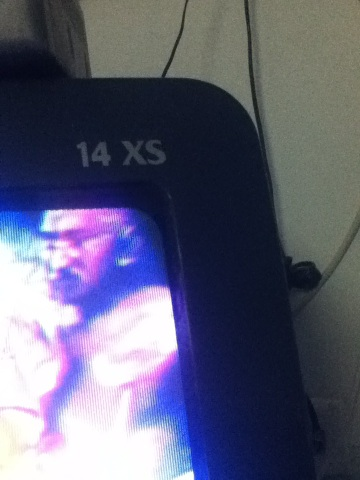Can you identify what this image is depicting? The image appears to be a close-up shot of a television or monitor displaying part of what might be a scene from a video or television program, with the text '14 XS' visible. Due to the blurry nature, it's challenging to identify precise details of the scene being displayed. Is there any part of the image that stands out despite the blur? The most distinctive element is the text '14 XS' on the device, which likely indicates the model or specification of the television or monitor. This detail stands out clearly against the surrounding elements. Imagining the best possible scenario, what could the video on screen be showing? In an imaginative scenario, the video on the screen could be showing a dramatic scene from a thrilling action movie where the protagonist is in a tense confrontation, set under vivid and colorful lighting that artistically blurs the visuals. This could represent an intense, climactic moment in the storyline. Provide a brief summary of what this video might be about. Given the visual setting and dramatic lighting, the video might be about a high-stakes adventure or action movie where heroes face critical challenges and confront antagonists to save something valuable or protect loved ones. Can you imagine a very creative plot that the video could be part of? Certainly! Imagine a sci-fi epic where Earth’s last surviving humans have embarked on a journey across galaxies to find a new habitable planet. The video captures a moment when our brave crew faces a galactic council, negotiating their right to settle on a promising new world. Emotions run high as colorful interstellar beings debate humanity's fate. 